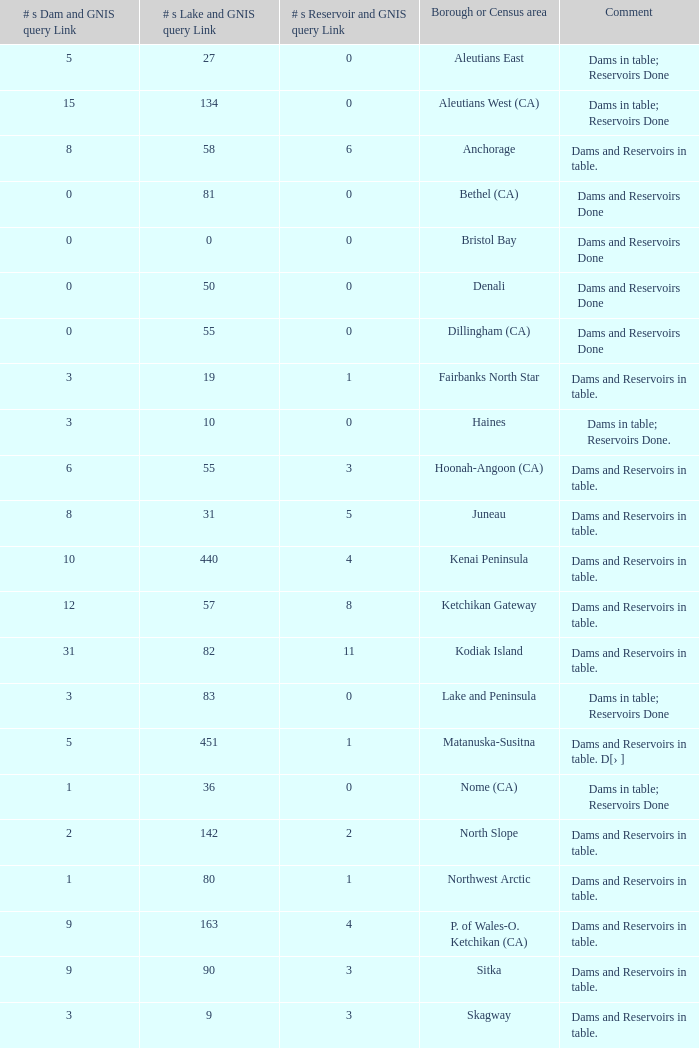List the highest number of dams along with the gnis query link for borough or census area in fairbanks north star. 3.0. 